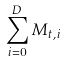Convert formula to latex. <formula><loc_0><loc_0><loc_500><loc_500>\sum _ { i = 0 } ^ { D } M _ { t , i }</formula> 